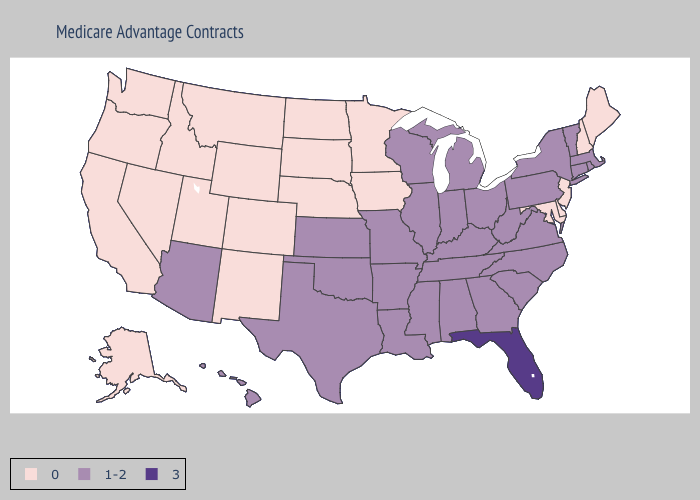Which states have the highest value in the USA?
Give a very brief answer. Florida. Name the states that have a value in the range 3?
Give a very brief answer. Florida. Name the states that have a value in the range 3?
Keep it brief. Florida. What is the value of Montana?
Write a very short answer. 0. Does Indiana have the lowest value in the MidWest?
Write a very short answer. No. Name the states that have a value in the range 0?
Write a very short answer. Alaska, California, Colorado, Delaware, Iowa, Idaho, Maryland, Maine, Minnesota, Montana, North Dakota, Nebraska, New Hampshire, New Jersey, New Mexico, Nevada, Oregon, South Dakota, Utah, Washington, Wyoming. Name the states that have a value in the range 3?
Write a very short answer. Florida. Does Alabama have a lower value than Iowa?
Keep it brief. No. Which states have the highest value in the USA?
Keep it brief. Florida. What is the value of Rhode Island?
Answer briefly. 1-2. Which states have the lowest value in the MidWest?
Concise answer only. Iowa, Minnesota, North Dakota, Nebraska, South Dakota. What is the lowest value in the USA?
Be succinct. 0. What is the lowest value in the USA?
Give a very brief answer. 0. Does the first symbol in the legend represent the smallest category?
Concise answer only. Yes. Does Alaska have the lowest value in the USA?
Be succinct. Yes. 